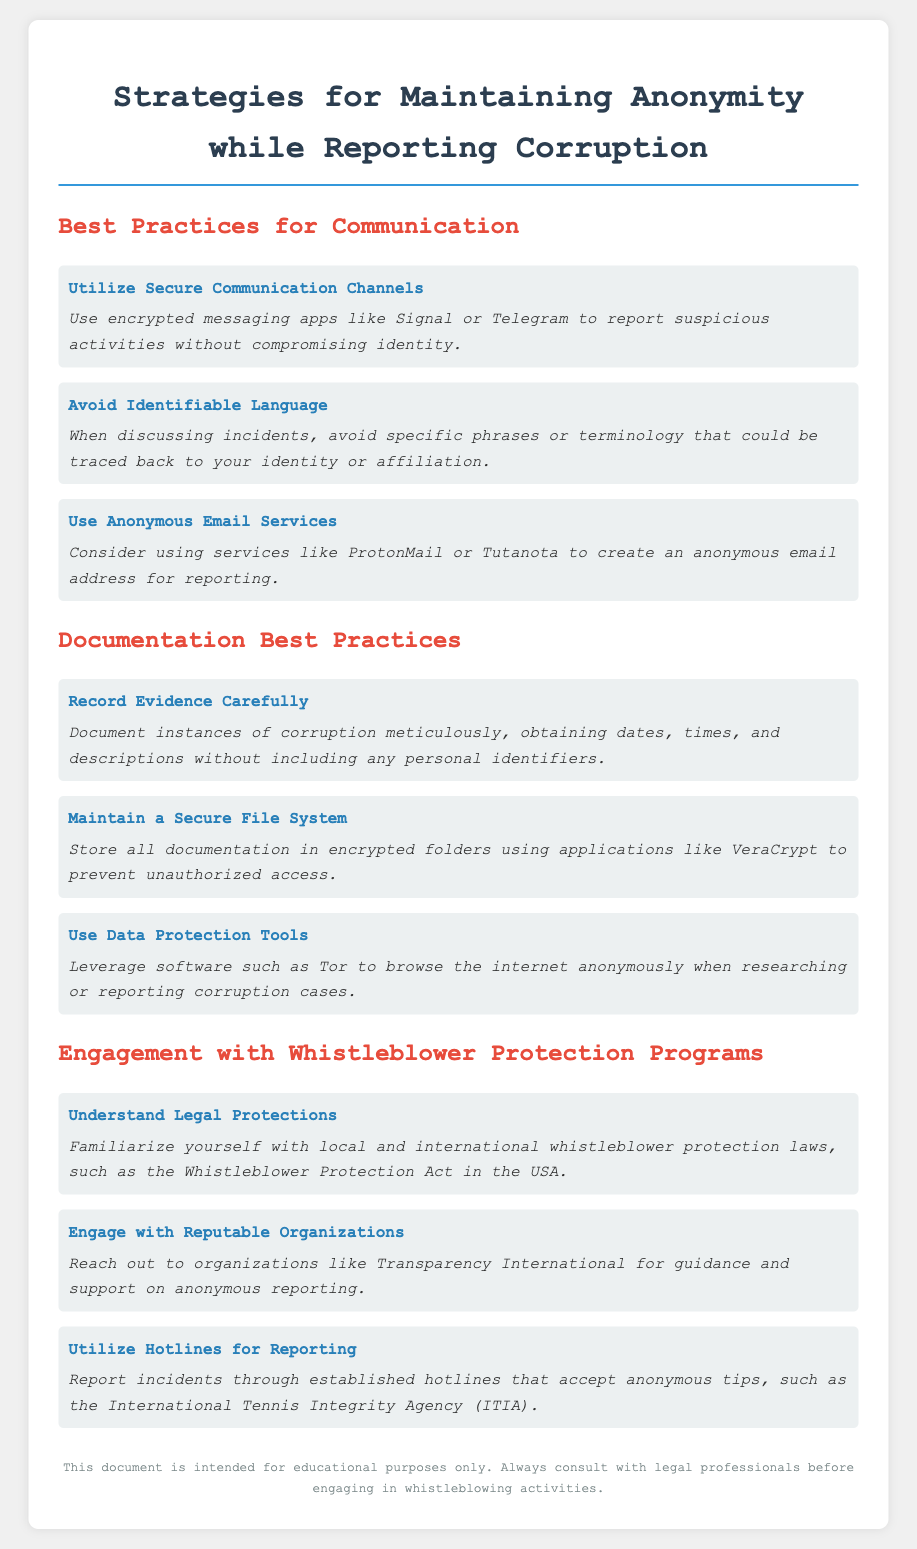What is the title of the document? The title is the main heading of the document, which indicates its focus on corruption reporting strategies.
Answer: Strategies for Maintaining Anonymity while Reporting Corruption What is one secure communication channel mentioned? This question asks for a specific example of a secure communication method listed in the document.
Answer: Signal What should you avoid when discussing incidents? The document suggests practices for effectively remaining anonymous while discussing incidents of corruption.
Answer: Identifiable Language What type of email service is recommended for anonymity? The document provides suggestions for email services that help maintain anonymity when reporting.
Answer: ProtonMail Which organization can you reach out to for support? This question addresses the resources available to those seeking guidance on anonymous reporting.
Answer: Transparency International What should be recorded carefully in documentation? This asks for a specific action that is emphasized in the documentation best practices section.
Answer: Evidence What type of tool should be leveraged for anonymous browsing? The question focuses on tools that enhance anonymity for research and reporting.
Answer: Tor What is the name of the whistleblower protection act in the USA? This question looks for specific legal terminology related to whistleblower protections mentioned in the document.
Answer: Whistleblower Protection Act What does ITIA stand for? The acronym is introduced in the context of reporting and requires recognition of the organization mentioned in the document.
Answer: International Tennis Integrity Agency 